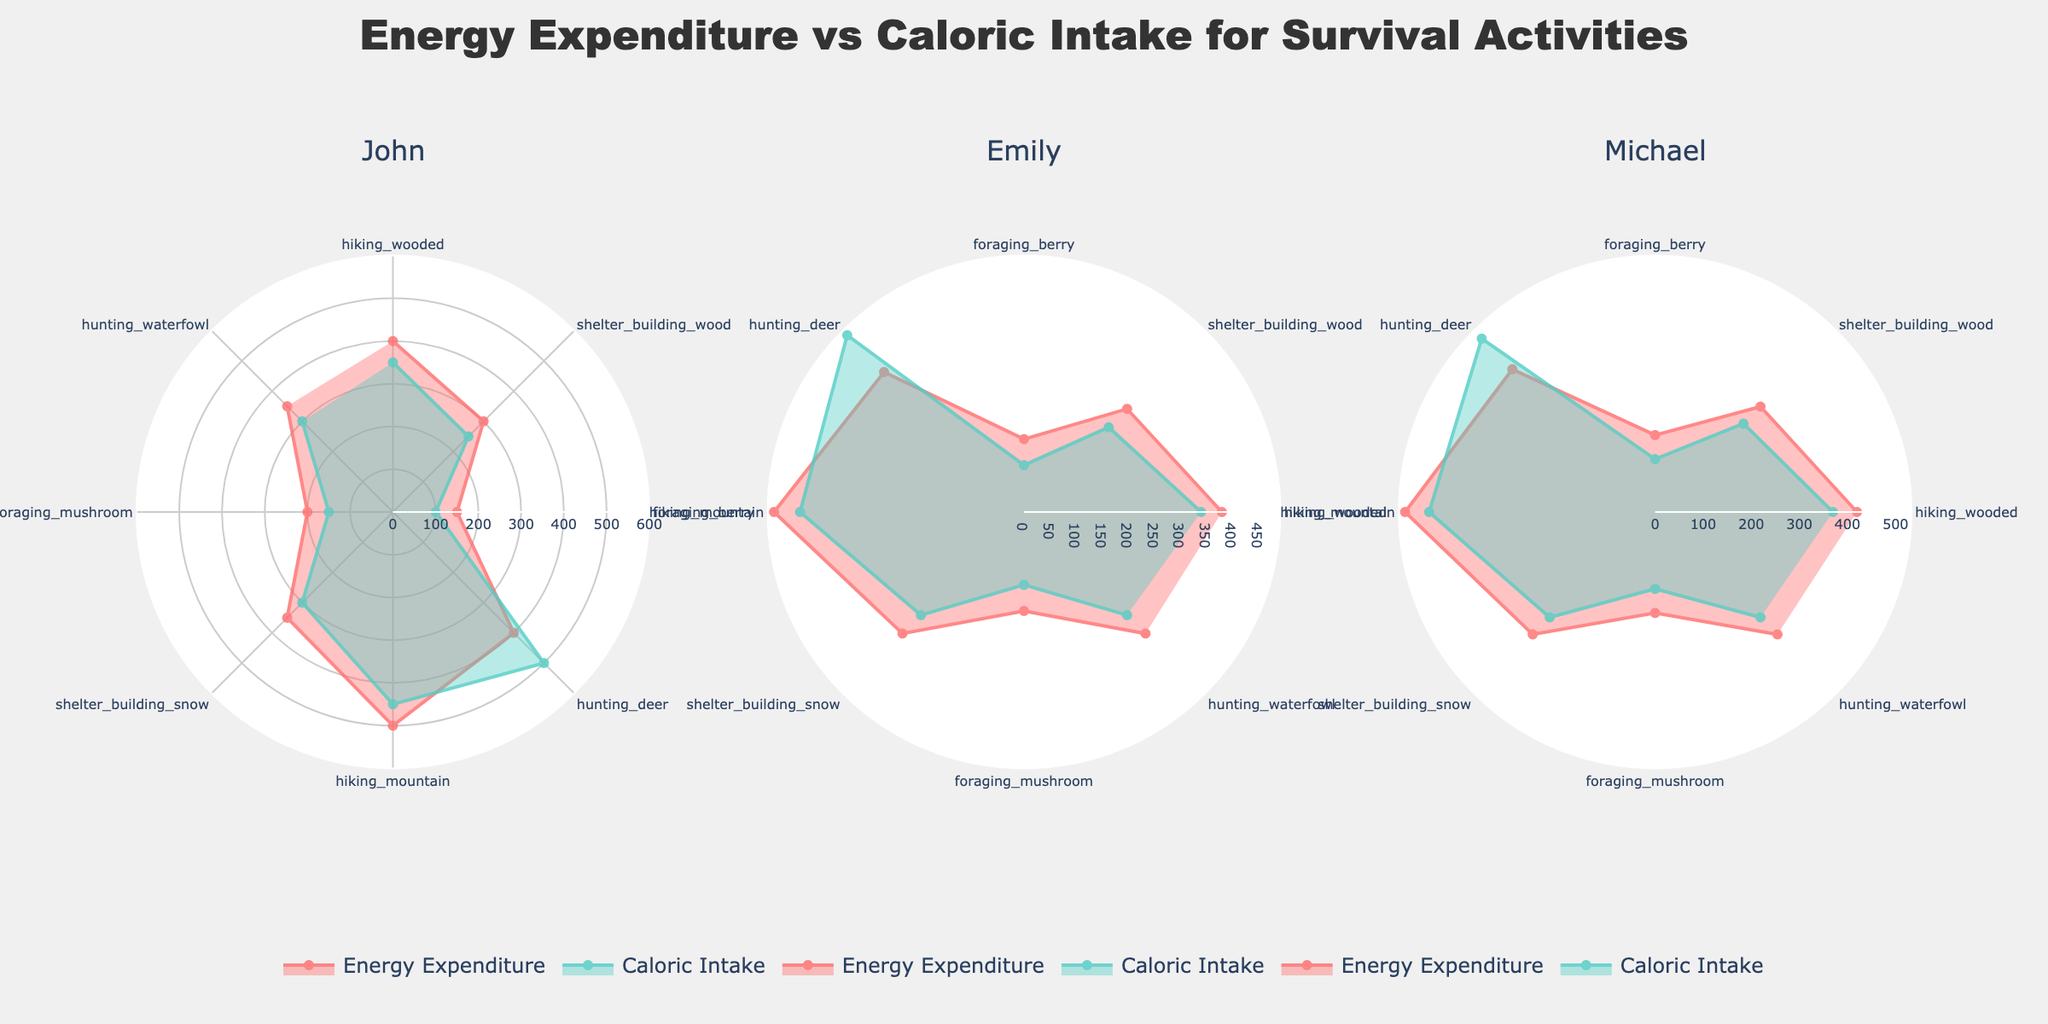What is the title of the figure? The title is usually prominently displayed at the top of the figure. By looking at the top central part of the figure, you can find the title text.
Answer: Energy Expenditure vs Caloric Intake for Survival Activities What are the two datasets compared in each subplot? Each subplot in the radar chart compares two datasets: Energy Expenditure and Caloric Intake. These labels are usually indicated in the legend.
Answer: Energy Expenditure and Caloric Intake How many activities are shown in each subplot? Count the number of distinct activity labels along the angular axis of one subplot. Each subplot should have the same activities listed in the same sequence.
Answer: Eight Which activity has the highest caloric intake for Michael? Identify the peak point on the "Caloric Intake" radar plot for Michael’s subplot and note the corresponding activity.
Answer: Hunting Deer Which individual has the highest energy expenditure for hiking on a mountain? Find the peak values for the "Energy Expenditure" dataset in each hiking mountain segment across all subplots, then compare them.
Answer: Michael Is there any activity where John's caloric intake is higher than his energy expenditure? Look at each activity segment in John's subplot and compare the lengths of the "Caloric Intake" and "Energy Expenditure" datasets for any one activity where the caloric intake exceeds energy expenditure.
Answer: Hunting Deer How does Emily's energy expenditure for shelter building with wood compare to her caloric intake for the same activity? Find the segment representing shelter building with wood in Emily's subplot and compare the lengths of the "Energy Expenditure" and "Caloric Intake" datasets.
Answer: Energy expenditure is higher Which activity shows the smallest difference between energy expenditure and caloric intake for each individual? For each subplot, visually identify the activity segment where the difference between the lengths of the datasets for energy expenditure and caloric intake is minimal.
Answer: Foraging Berry Across all individuals, which activity tends to have a higher energy expenditure compared to its respective caloric intake? Identify the activities in all three subplots where the energy expenditure exceeds the caloric intake, then determine which activity is consistently higher among all individuals.
Answer: Shelter Building Wood 